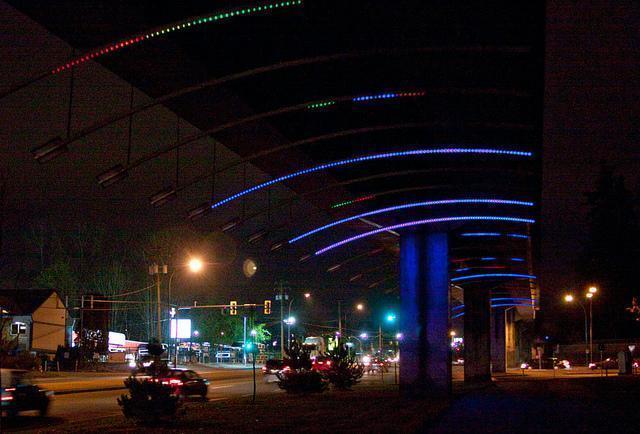The area underneath the structure is illuminated by what?
Select the accurate answer and provide explanation: 'Answer: answer
Rationale: rationale.'
Options: Fluorescent lights, hps lights, led lights, incandescent lights. Answer: led lights.
Rationale: The illumination is 90% greater using this method. 